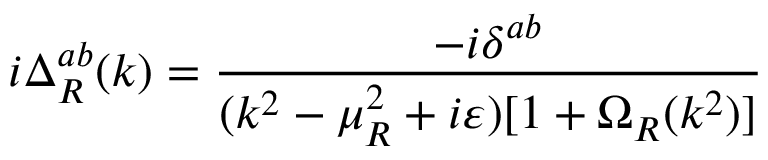Convert formula to latex. <formula><loc_0><loc_0><loc_500><loc_500>i \Delta _ { R } ^ { a b } ( k ) = \frac { - i \delta ^ { a b } } { ( k ^ { 2 } - \mu _ { R } ^ { 2 } + i \varepsilon ) [ 1 + \Omega _ { R } ( k ^ { 2 } ) ] }</formula> 